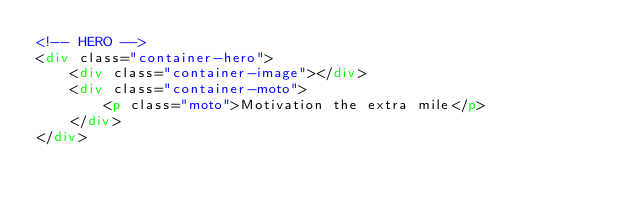<code> <loc_0><loc_0><loc_500><loc_500><_HTML_><!-- HERO -->
<div class="container-hero">
    <div class="container-image"></div>
    <div class="container-moto">
        <p class="moto">Motivation the extra mile</p>
    </div>
</div></code> 